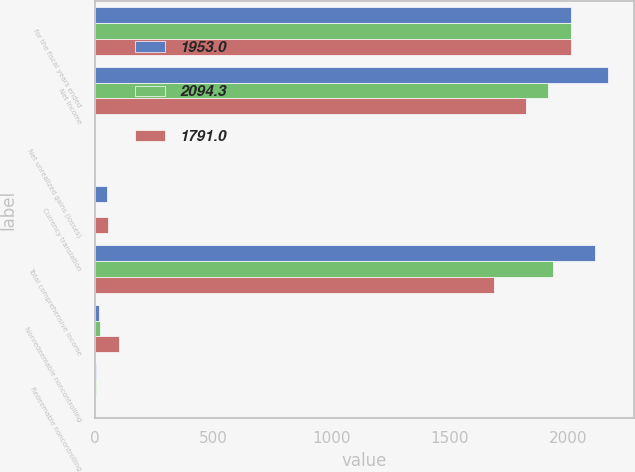Convert chart to OTSL. <chart><loc_0><loc_0><loc_500><loc_500><stacked_bar_chart><ecel><fcel>for the fiscal years ended<fcel>Net Income<fcel>Net unrealized gains (losses)<fcel>Currency translation<fcel>Total comprehensive income<fcel>Nonredeemable noncontrolling<fcel>Redeemable noncontrolling<nl><fcel>1953<fcel>2013<fcel>2170.7<fcel>1.7<fcel>49.5<fcel>2114.8<fcel>16.9<fcel>3.6<nl><fcel>2094.3<fcel>2012<fcel>1915.5<fcel>0.9<fcel>0.3<fcel>1937.1<fcel>20.9<fcel>5<nl><fcel>1791<fcel>2011<fcel>1820.8<fcel>0.3<fcel>53.7<fcel>1688.2<fcel>101.6<fcel>1.2<nl></chart> 